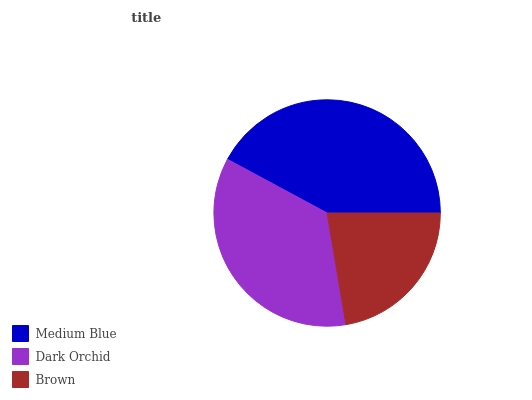Is Brown the minimum?
Answer yes or no. Yes. Is Medium Blue the maximum?
Answer yes or no. Yes. Is Dark Orchid the minimum?
Answer yes or no. No. Is Dark Orchid the maximum?
Answer yes or no. No. Is Medium Blue greater than Dark Orchid?
Answer yes or no. Yes. Is Dark Orchid less than Medium Blue?
Answer yes or no. Yes. Is Dark Orchid greater than Medium Blue?
Answer yes or no. No. Is Medium Blue less than Dark Orchid?
Answer yes or no. No. Is Dark Orchid the high median?
Answer yes or no. Yes. Is Dark Orchid the low median?
Answer yes or no. Yes. Is Medium Blue the high median?
Answer yes or no. No. Is Medium Blue the low median?
Answer yes or no. No. 